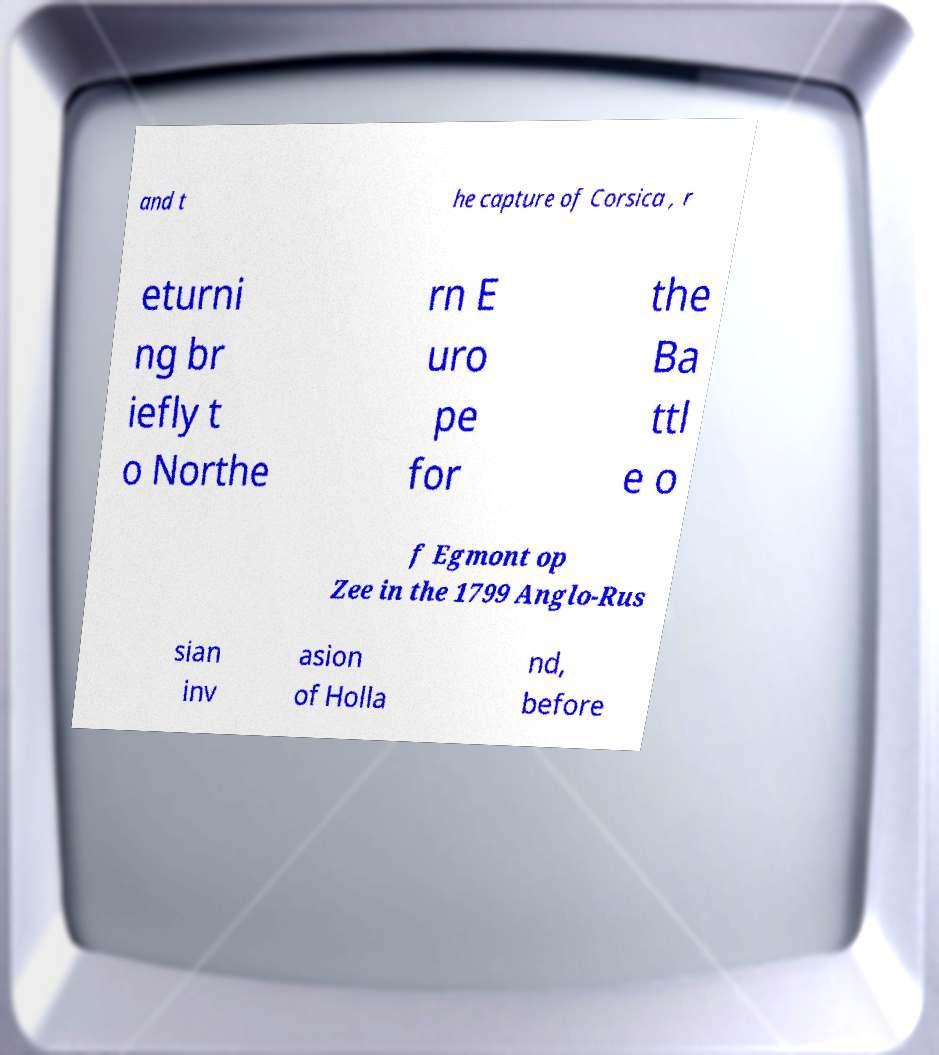Please identify and transcribe the text found in this image. and t he capture of Corsica , r eturni ng br iefly t o Northe rn E uro pe for the Ba ttl e o f Egmont op Zee in the 1799 Anglo-Rus sian inv asion of Holla nd, before 